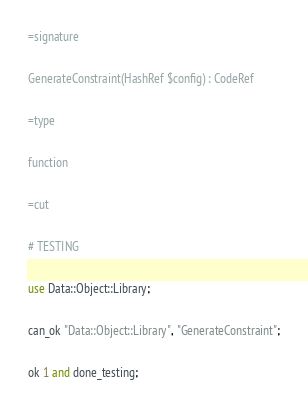<code> <loc_0><loc_0><loc_500><loc_500><_Perl_>=signature

GenerateConstraint(HashRef $config) : CodeRef

=type

function

=cut

# TESTING

use Data::Object::Library;

can_ok "Data::Object::Library", "GenerateConstraint";

ok 1 and done_testing;
</code> 